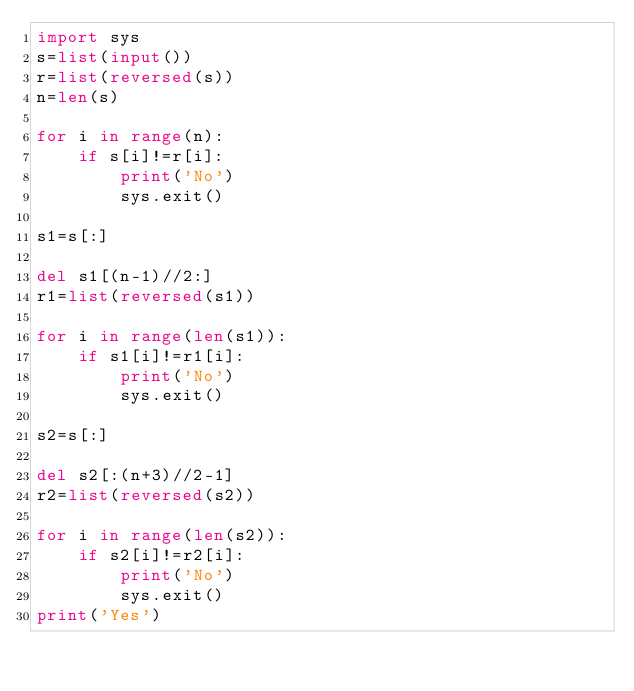<code> <loc_0><loc_0><loc_500><loc_500><_Python_>import sys
s=list(input())
r=list(reversed(s))
n=len(s)

for i in range(n):
    if s[i]!=r[i]:
        print('No')
        sys.exit()

s1=s[:]

del s1[(n-1)//2:]
r1=list(reversed(s1))

for i in range(len(s1)):
    if s1[i]!=r1[i]:
        print('No')
        sys.exit()

s2=s[:]

del s2[:(n+3)//2-1]
r2=list(reversed(s2))

for i in range(len(s2)):
    if s2[i]!=r2[i]:
        print('No')
        sys.exit()
print('Yes')</code> 